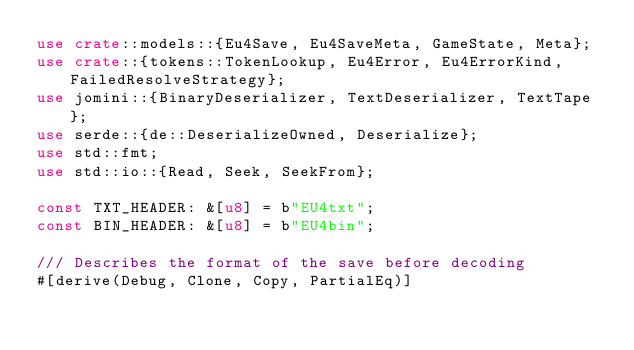<code> <loc_0><loc_0><loc_500><loc_500><_Rust_>use crate::models::{Eu4Save, Eu4SaveMeta, GameState, Meta};
use crate::{tokens::TokenLookup, Eu4Error, Eu4ErrorKind, FailedResolveStrategy};
use jomini::{BinaryDeserializer, TextDeserializer, TextTape};
use serde::{de::DeserializeOwned, Deserialize};
use std::fmt;
use std::io::{Read, Seek, SeekFrom};

const TXT_HEADER: &[u8] = b"EU4txt";
const BIN_HEADER: &[u8] = b"EU4bin";

/// Describes the format of the save before decoding
#[derive(Debug, Clone, Copy, PartialEq)]</code> 